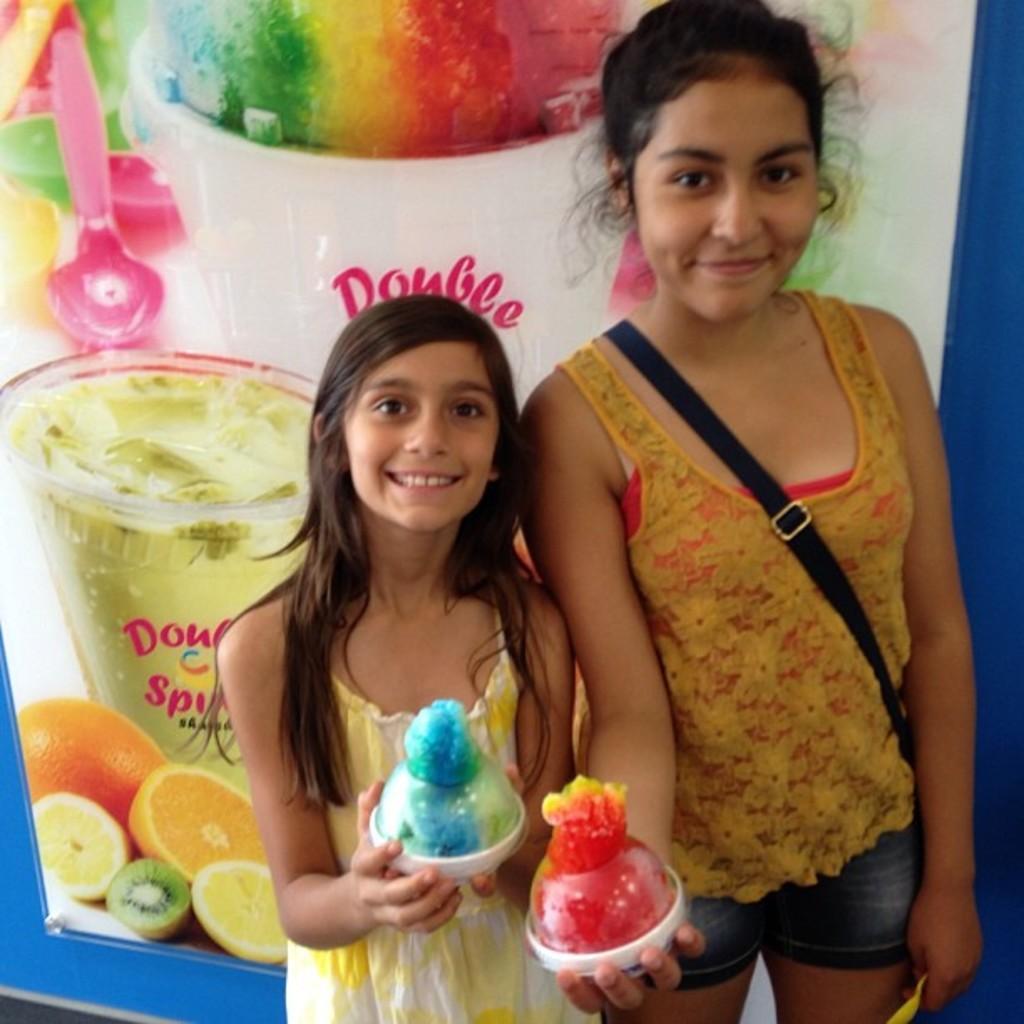Please provide a concise description of this image. In this picture we can see two women,they are smiling,they are holding some objects and in the background we can see a poster. 